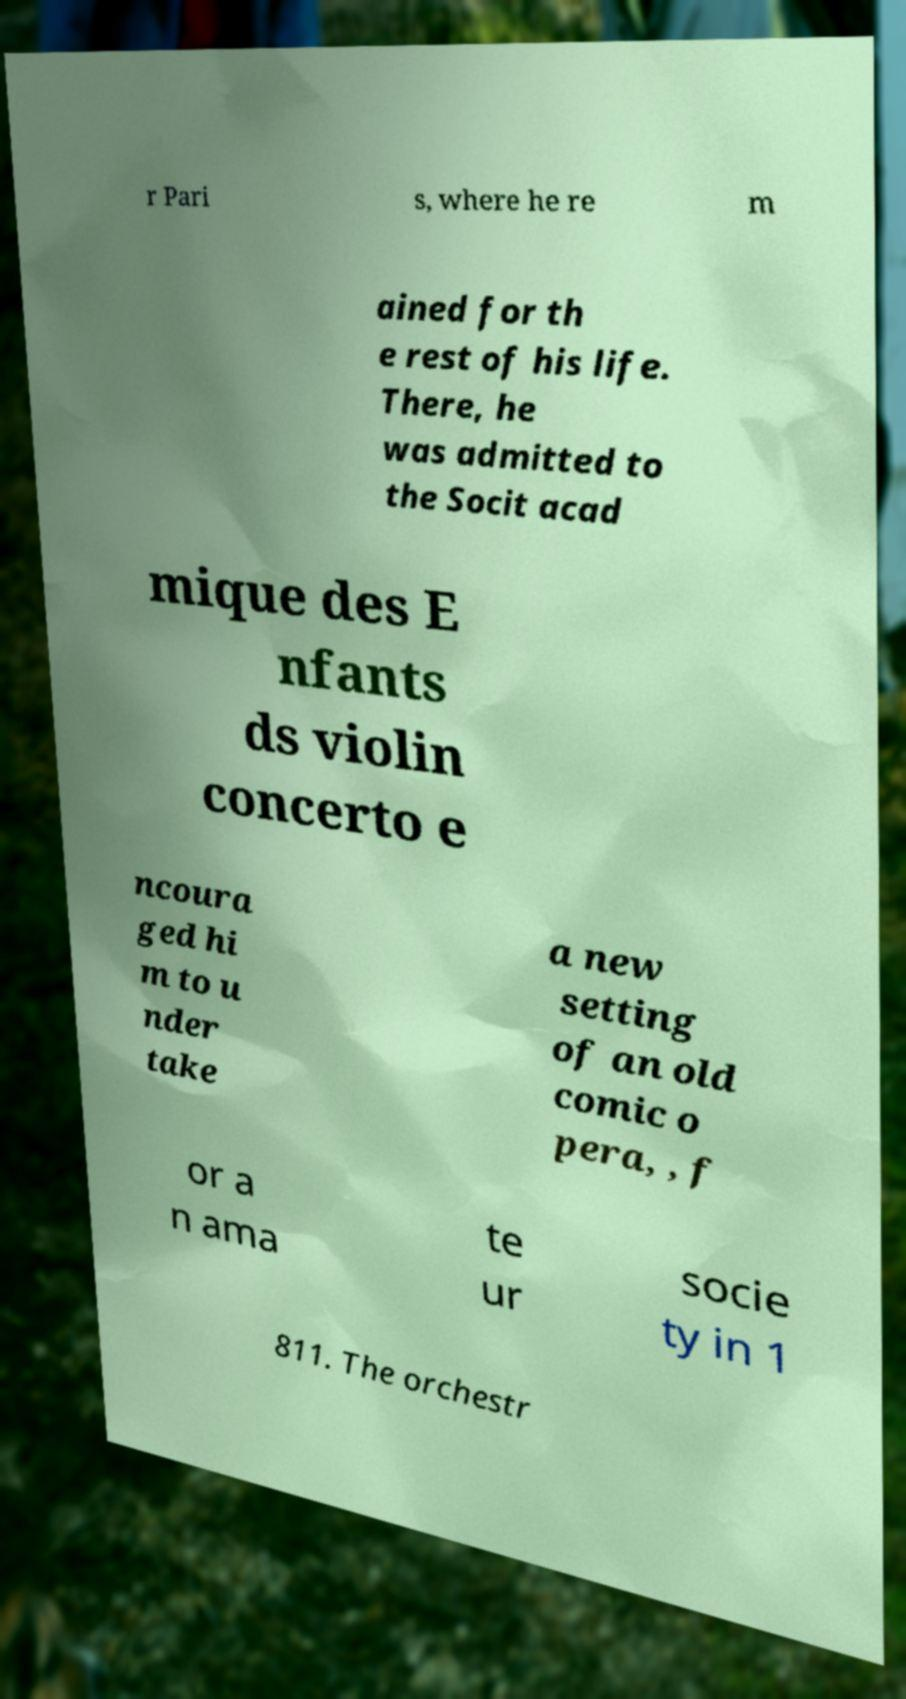What messages or text are displayed in this image? I need them in a readable, typed format. r Pari s, where he re m ained for th e rest of his life. There, he was admitted to the Socit acad mique des E nfants ds violin concerto e ncoura ged hi m to u nder take a new setting of an old comic o pera, , f or a n ama te ur socie ty in 1 811. The orchestr 